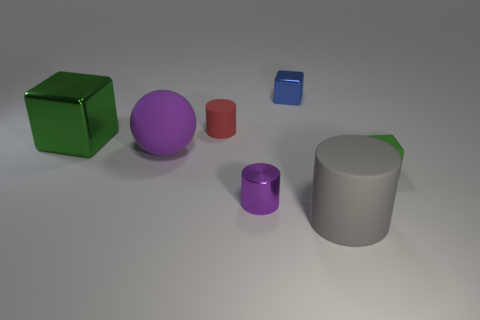Subtract all gray matte cylinders. How many cylinders are left? 2 Subtract all green cubes. How many cubes are left? 1 Subtract 1 blocks. How many blocks are left? 2 Add 2 big green shiny cubes. How many objects exist? 9 Subtract all cubes. How many objects are left? 4 Subtract all brown cubes. Subtract all green spheres. How many cubes are left? 3 Subtract all cyan spheres. How many purple cubes are left? 0 Subtract all blue shiny things. Subtract all matte cubes. How many objects are left? 5 Add 1 green rubber cubes. How many green rubber cubes are left? 2 Add 6 red matte cylinders. How many red matte cylinders exist? 7 